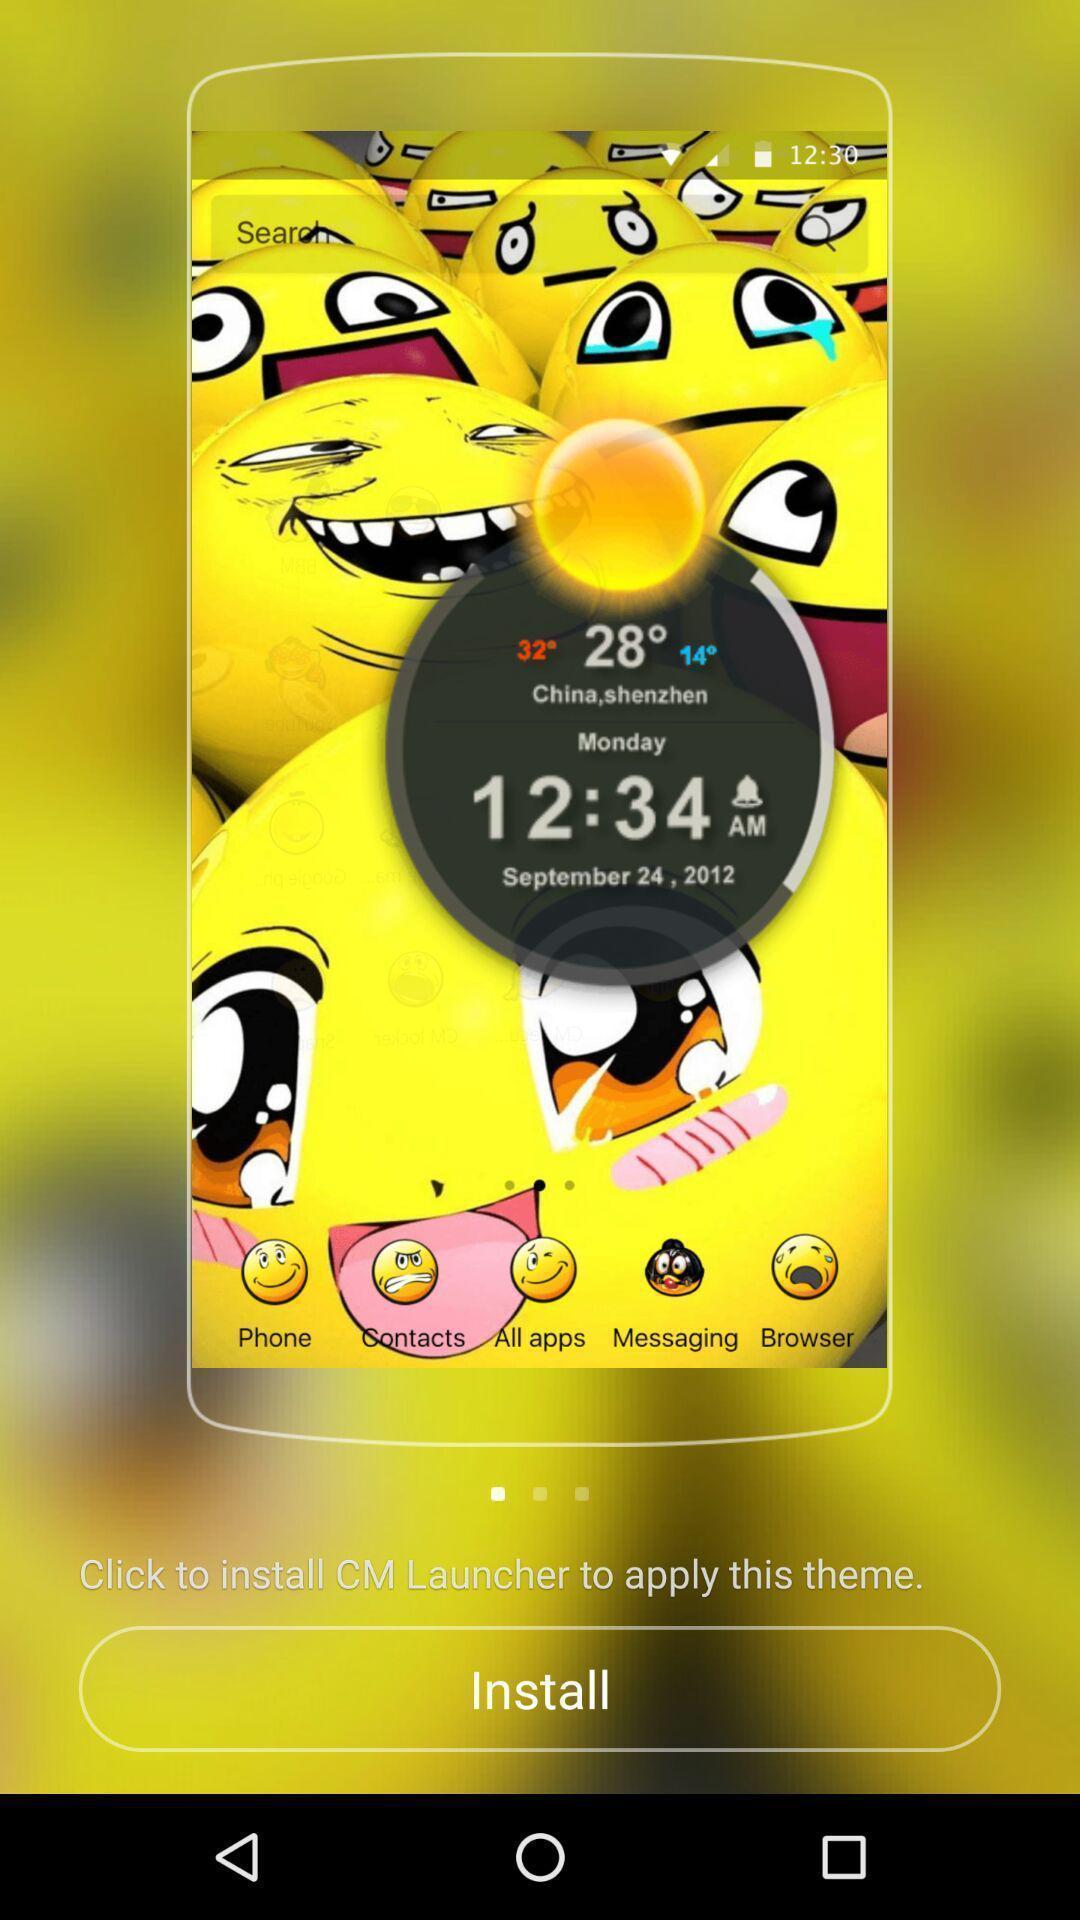What is the overall content of this screenshot? Page displaying to install an application. 